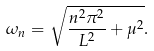<formula> <loc_0><loc_0><loc_500><loc_500>\omega _ { n } = \sqrt { \frac { n ^ { 2 } \pi ^ { 2 } } { L ^ { 2 } } + \mu ^ { 2 } } .</formula> 